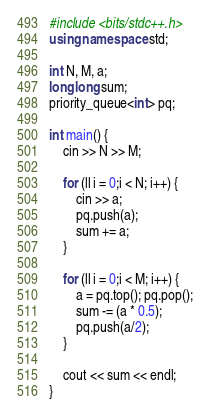<code> <loc_0><loc_0><loc_500><loc_500><_C++_>#include <bits/stdc++.h>
using namespace std;

int N, M, a;
long long sum;
priority_queue<int> pq;

int main() {
    cin >> N >> M;

    for (ll i = 0;i < N; i++) {
        cin >> a;
        pq.push(a);
        sum += a;
    }

    for (ll i = 0;i < M; i++) {
    	a = pq.top(); pq.pop();
    	sum -= (a * 0.5);
    	pq.push(a/2);
    }

    cout << sum << endl;
}
</code> 